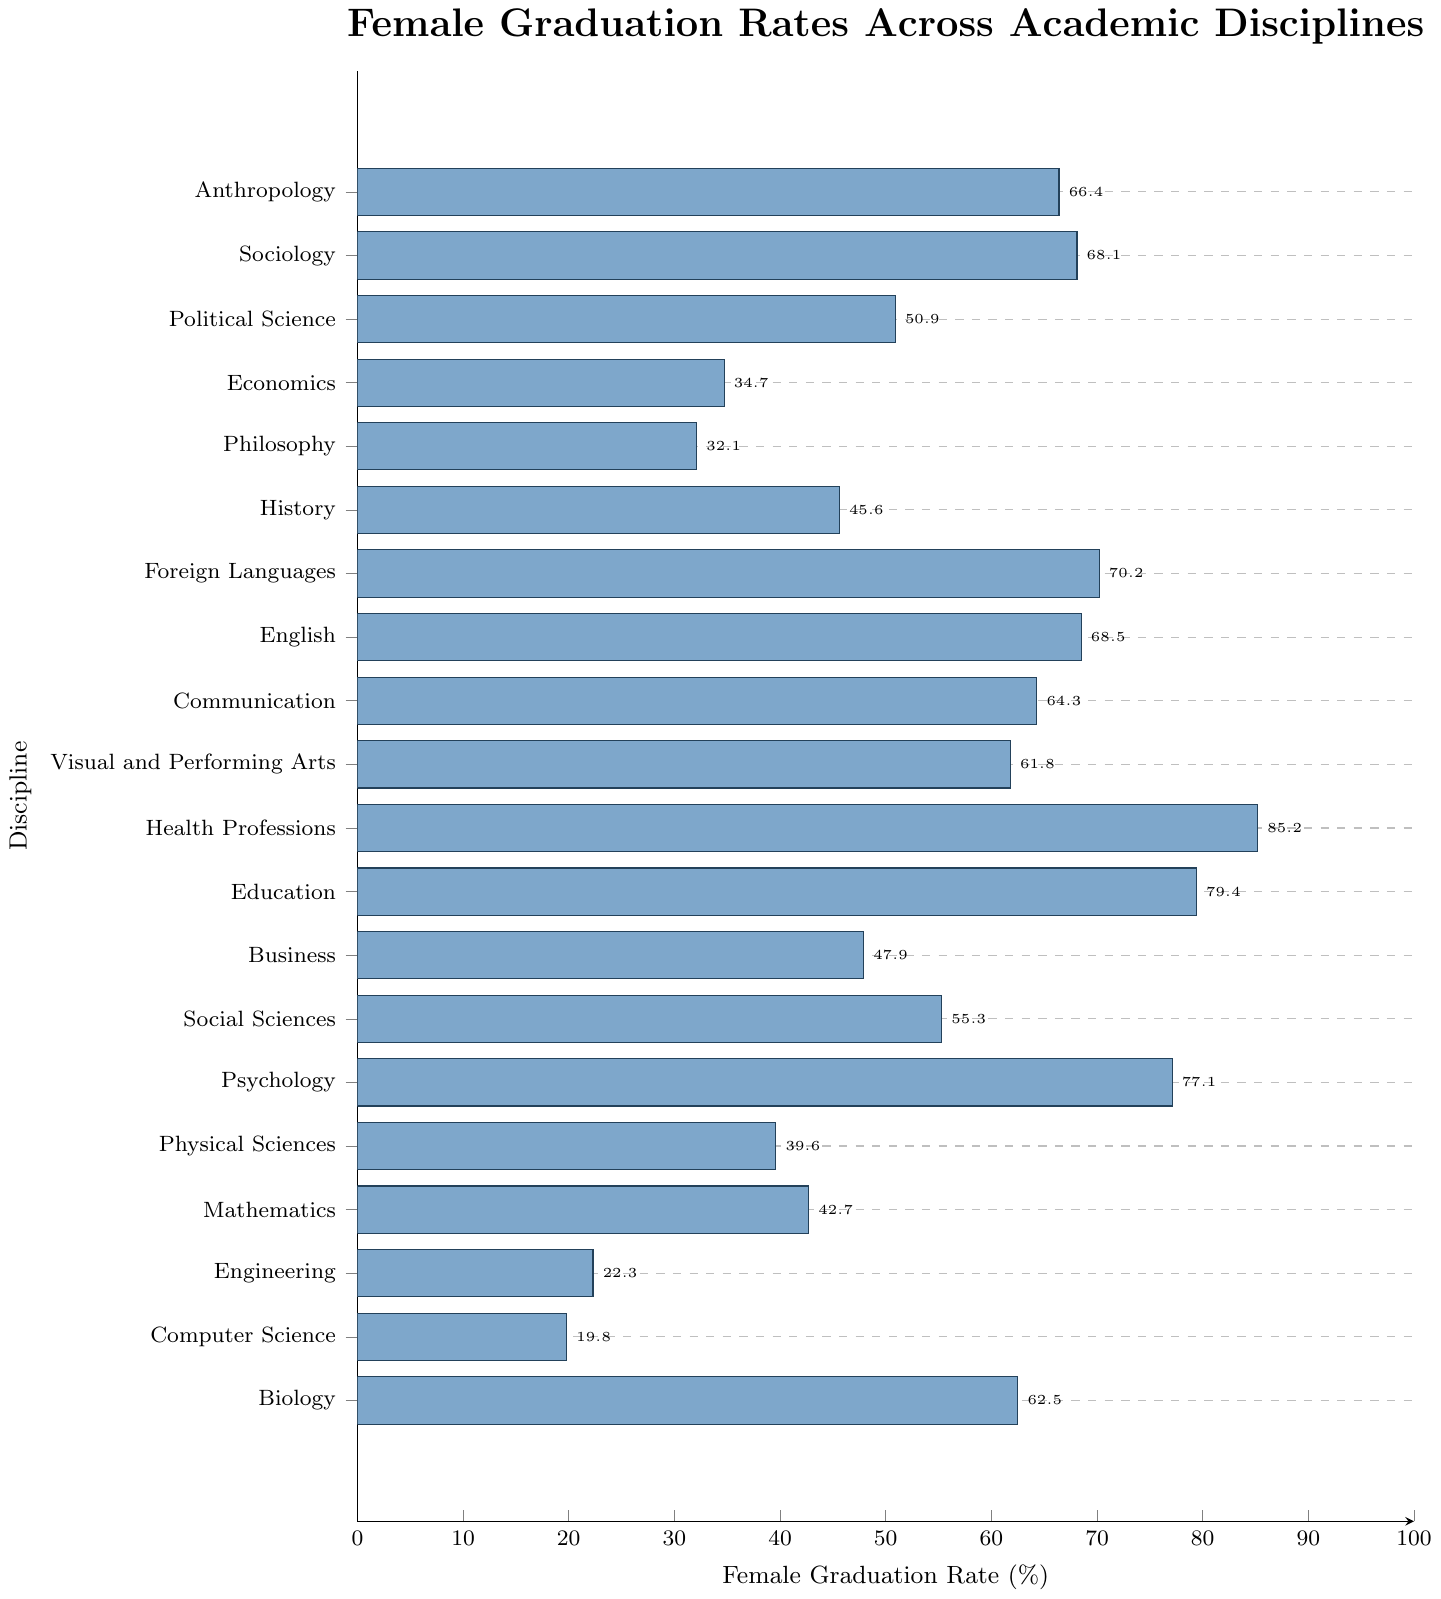What discipline has the highest female graduation rate? The bar corresponding to Health Professions is the longest, indicating the highest rate.
Answer: Health Professions Which discipline has the lowest female graduation rate? The bar representing Computer Science is the shortest, indicating the lowest rate.
Answer: Computer Science Compare the female graduation rates of Engineering and Mathematics. Which is higher? The bar for Mathematics is longer than the one for Engineering, indicating a higher female graduation rate.
Answer: Mathematics How many disciplines have a female graduation rate higher than 50%? Count the bars that extend beyond the 50% mark: 10 disciplines (Anthropology, Sociology, Political Science, Foreign Languages, English, Communication, Visual and Performing Arts, Health Professions, Education, Psychology).
Answer: 10 Is the female graduation rate for Sociology closer to the rate for Political Science or Visual and Performing Arts? Compare the lengths of the bars: Sociology (68.1%), Political Science (50.9%), and Visual and Performing Arts (61.8%). Sociology is closer to Visual and Performing Arts.
Answer: Visual and Performing Arts What is the median female graduation rate among all the disciplines? List the graduation rates in ascending order and find the middle value: 32.1, 34.7, 39.6, 42.7, 45.6, 47.9, 50.9, 55.3, 61.8, 62.5, 64.3, 66.4, 68.1, 68.5, 70.2, 77.1, 79.4, 85.2. The median (middle) value is 61.8%.
Answer: 61.8% What is the ratio of the female graduation rate in Education to that in Computer Science? The rate in Education is 79.4% and in Computer Science is 19.8%. The ratio is calculated as 79.4 / 19.8 ≈ 4.01.
Answer: 4.01 Calculate the average female graduation rate for the disciplines Mathematics, Physical Sciences, and Engineering. Sum the rates (42.7 + 39.6 + 22.3) and divide by the number of disciplines (3). The average rate is (42.7 + 39.6 + 22.3) / 3 = 34.87%.
Answer: 34.87% Which has a higher graduation rate: Foreign Languages or Communication? The bar for Foreign Languages is longer than the one for Communication, indicating a higher graduation rate.
Answer: Foreign Languages What percentage difference is there between the graduation rates of Psychology and Biology? Subtract the graduation rate of Biology (62.5%) from that of Psychology (77.1%) to find the difference: 77.1 - 62.5 = 14.6%.
Answer: 14.6% 